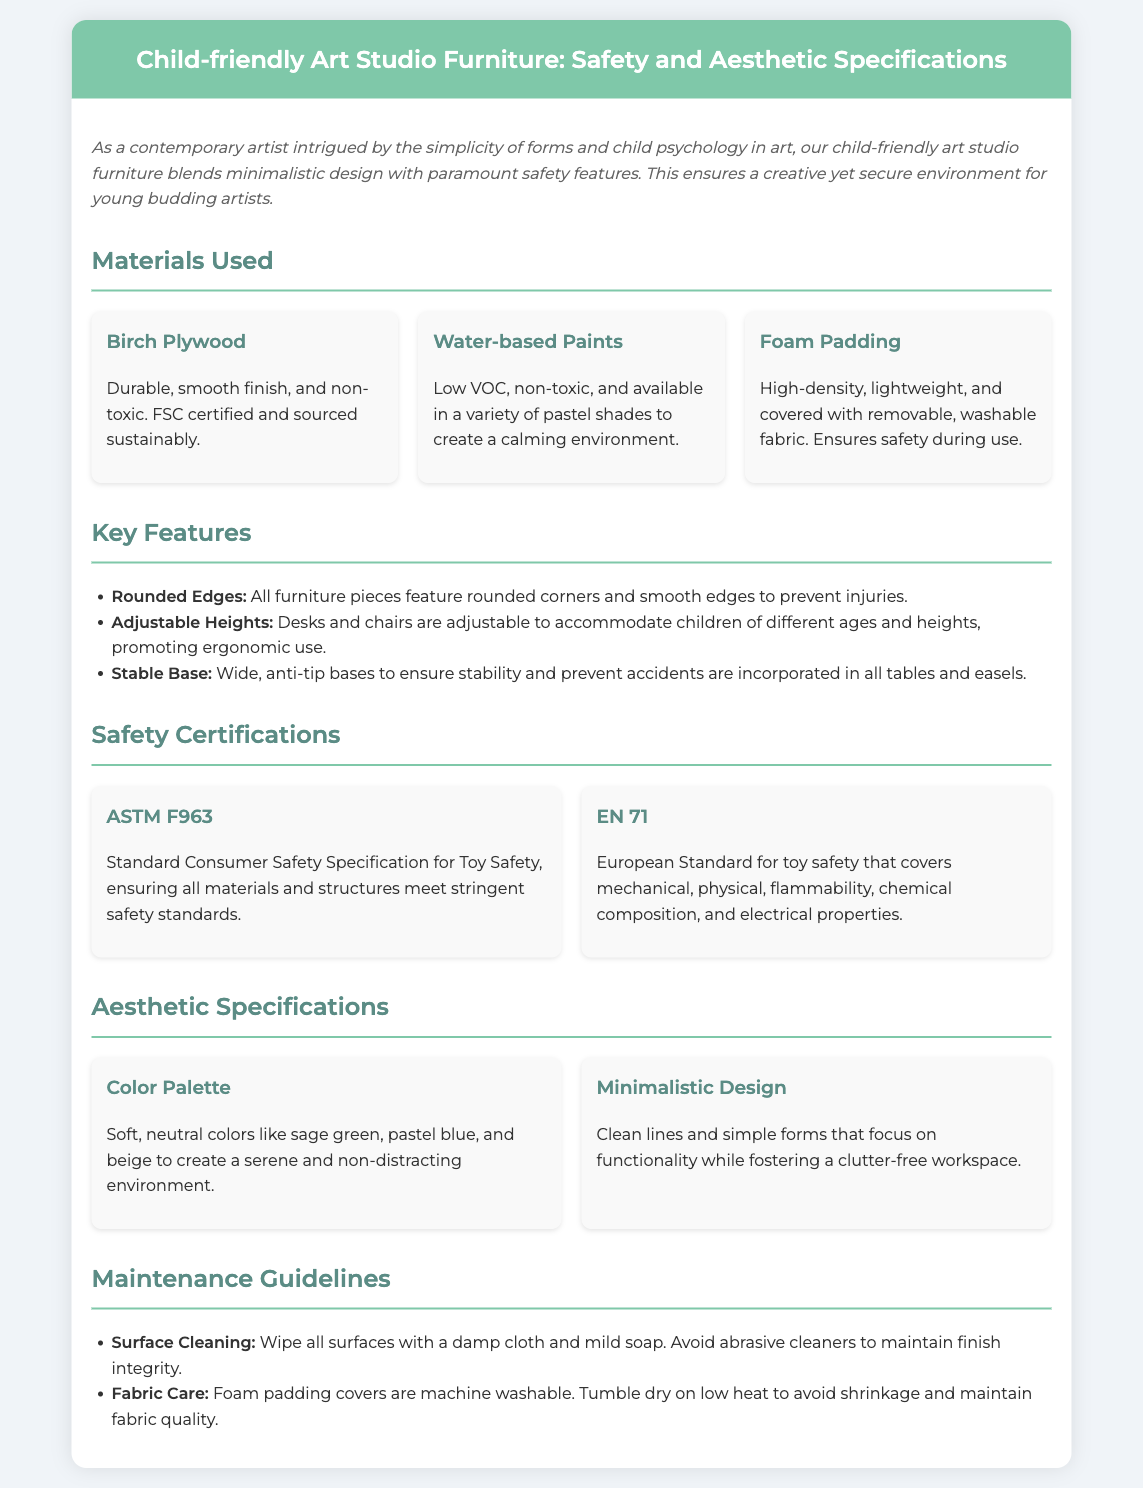what materials are used for the furniture? The document lists the materials used, which include Birch Plywood, Water-based Paints, and Foam Padding.
Answer: Birch Plywood, Water-based Paints, Foam Padding what safety certification does the furniture meet? The furniture meets the ASTM F963 and EN 71 safety certifications.
Answer: ASTM F963, EN 71 what is the primary color palette of the furniture? The aesthetic specifications mention soft, neutral colors like sage green, pastel blue, and beige as the primary color palette.
Answer: sage green, pastel blue, beige how many key features are listed in the document? The document lists three key features regarding safety and usability of the furniture.
Answer: three what type of design is emphasized in the aesthetic specifications? The aesthetic specifications emphasize a minimalistic design, focusing on clean lines and simplicity.
Answer: minimalistic design what are the maintenance guidelines for surface cleaning? The document suggests wiping surfaces with a damp cloth and mild soap to clean them.
Answer: wipe with a damp cloth and mild soap what is the purpose of using removable fabric on foam padding? The removable fabric on foam padding is emphasized for safety and maintenance ease.
Answer: safety and maintenance ease how does the furniture promote ergonomic use for children? The furniture promotes ergonomic use through adjustable heights for desks and chairs.
Answer: adjustable heights 